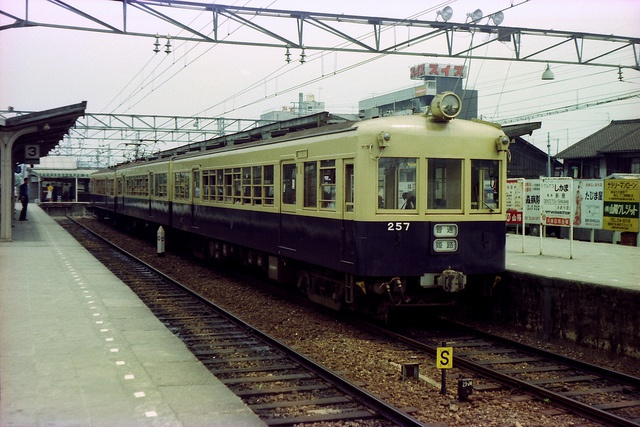Describe the objects in this image and their specific colors. I can see train in lavender, black, olive, gray, and darkgreen tones, people in lavender, black, gray, navy, and darkblue tones, people in lavender, black, gray, and darkgreen tones, people in lavender and black tones, and people in lavender, darkgray, black, and gray tones in this image. 